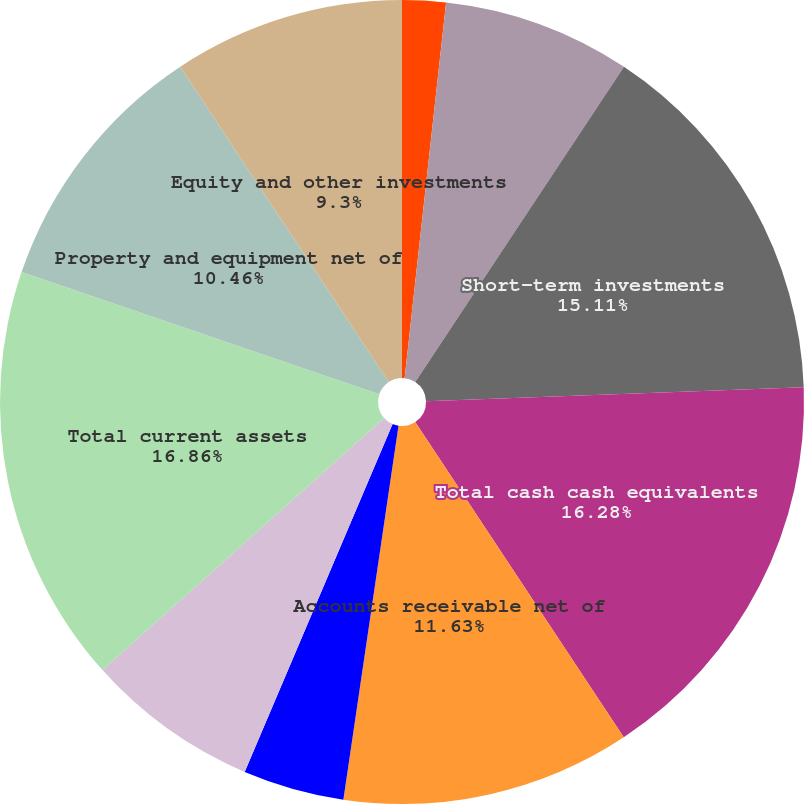Convert chart. <chart><loc_0><loc_0><loc_500><loc_500><pie_chart><fcel>June 30<fcel>Cash and cash equivalents<fcel>Short-term investments<fcel>Total cash cash equivalents<fcel>Accounts receivable net of<fcel>Inventories<fcel>Other<fcel>Total current assets<fcel>Property and equipment net of<fcel>Equity and other investments<nl><fcel>1.75%<fcel>7.56%<fcel>15.11%<fcel>16.28%<fcel>11.63%<fcel>4.07%<fcel>6.98%<fcel>16.86%<fcel>10.46%<fcel>9.3%<nl></chart> 